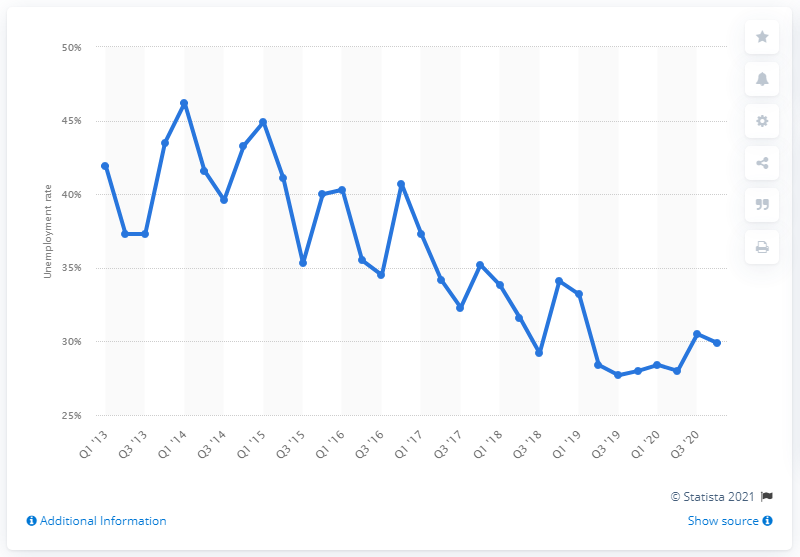Indicate a few pertinent items in this graphic. The unemployment rate among individuals aged 15-24 in Italy was 29.9% in the fourth quarter of 2020. 